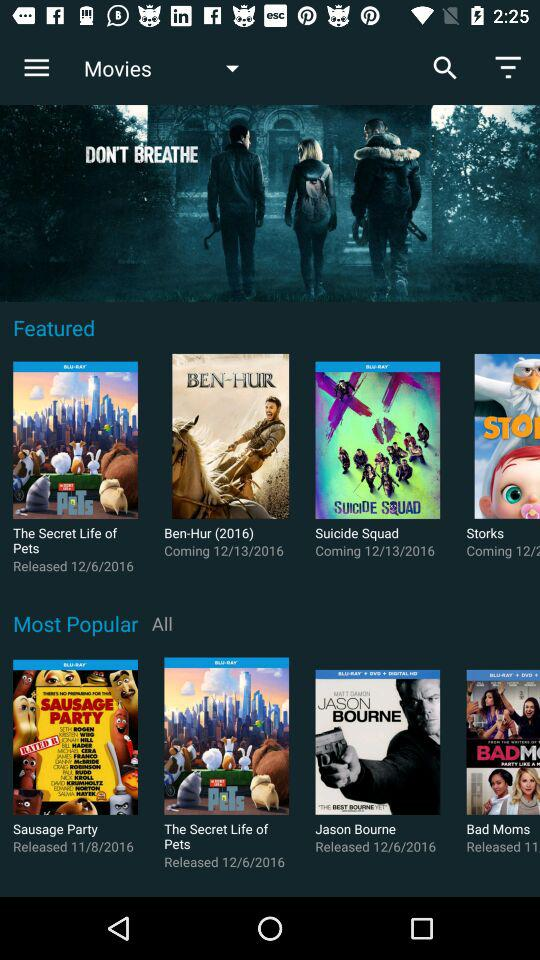When was the movie "The Secret Life of Pets" released? The movie "The Secret Life of Pets" was released on December 6, 2016. 